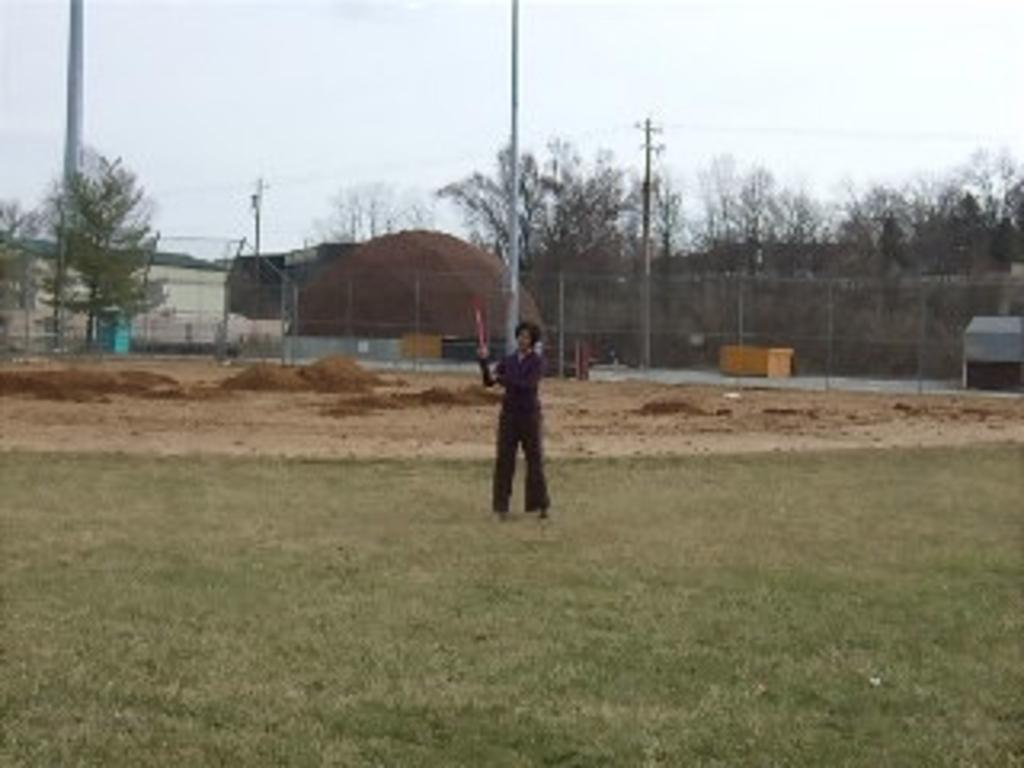What is the primary subject in the image? There is a woman standing in the image. What is the woman standing on? The woman is standing on grass. What type of terrain is visible in the image? There is mud visible in the image. What natural elements can be seen in the image? There are trees in the image. What man-made structures are present in the image? Electrical poles and a hut are present in the image. What type of reward does the woman receive for standing in the image? There is no indication in the image that the woman is receiving a reward for standing. 